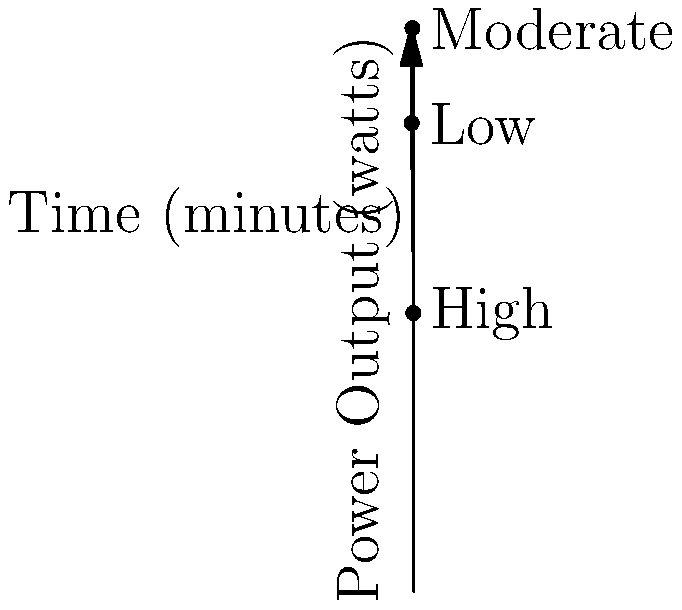Analyzing the power output curve of a wearable fitness tracker during a workout, at which intensity level does the rate of change in power output appear to be the highest? To determine where the rate of change in power output is highest, we need to analyze the slope of the curve at different points:

1. The curve represents power output (watts) over time (minutes) during a workout.
2. The rate of change is represented by the slope of the curve.
3. We can visually observe that the slope is steepest between the "Low" and "Moderate" intensity levels.
4. At the "Low" intensity point, the curve is rising rapidly.
5. As we move towards the "Moderate" intensity, the slope remains steep but starts to decrease.
6. Between "Moderate" and "High" intensities, the slope becomes less steep and eventually negative.
7. The highest rate of change (steepest slope) occurs just after the "Low" intensity point, as the curve transitions from low to moderate intensity.

Therefore, the rate of change in power output appears to be highest at the beginning of the moderate intensity level, just after the low intensity phase.
Answer: Beginning of moderate intensity 